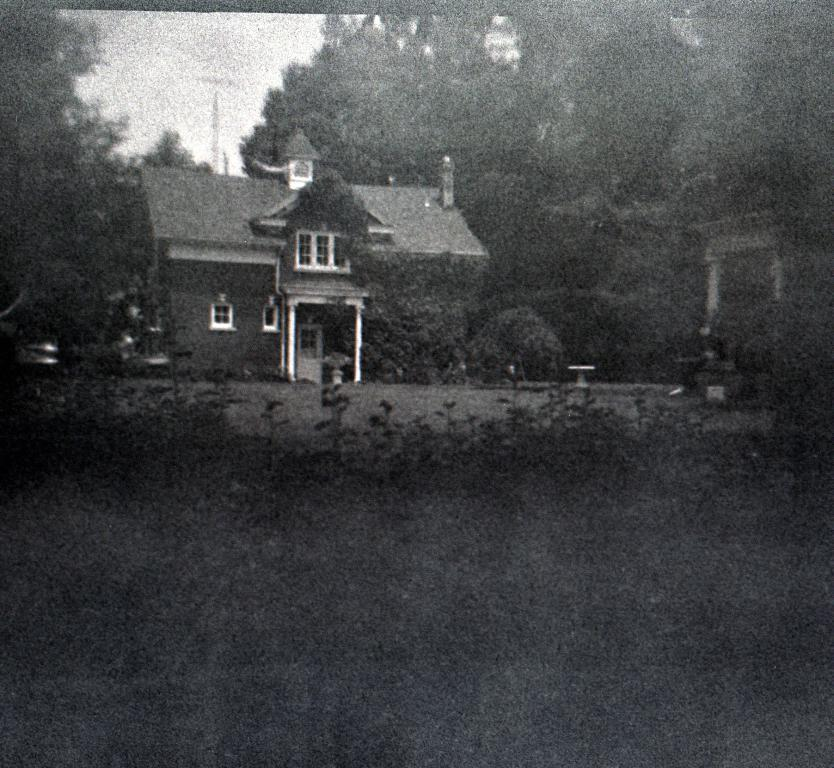What type of structure is present in the image? There is a house in the picture. What natural elements can be seen in the image? There are trees and plants in the picture. What part of the natural environment is visible in the image? The sky is visible in the picture. Can you see a porter carrying luggage near the house in the image? There is no porter or luggage present in the image. Is there a bike parked next to the house in the image? There is no bike present in the image. 